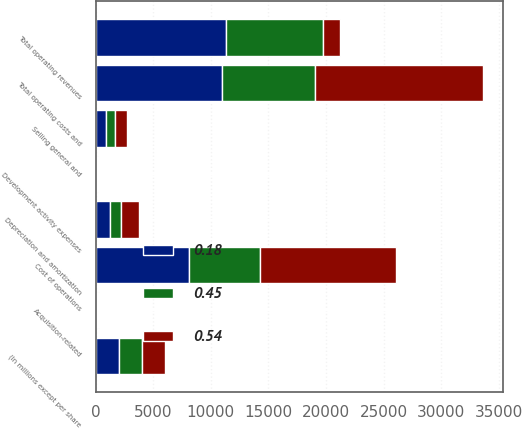<chart> <loc_0><loc_0><loc_500><loc_500><stacked_bar_chart><ecel><fcel>(In millions except per share<fcel>Total operating revenues<fcel>Cost of operations<fcel>Depreciation and amortization<fcel>Selling general and<fcel>Acquisition-related<fcel>Development activity expenses<fcel>Total operating costs and<nl><fcel>0.54<fcel>2014<fcel>1523<fcel>11779<fcel>1523<fcel>1042<fcel>84<fcel>91<fcel>14616<nl><fcel>0.18<fcel>2013<fcel>11295<fcel>8121<fcel>1256<fcel>904<fcel>128<fcel>84<fcel>10952<nl><fcel>0.45<fcel>2012<fcel>8422<fcel>6140<fcel>950<fcel>807<fcel>107<fcel>68<fcel>8072<nl></chart> 